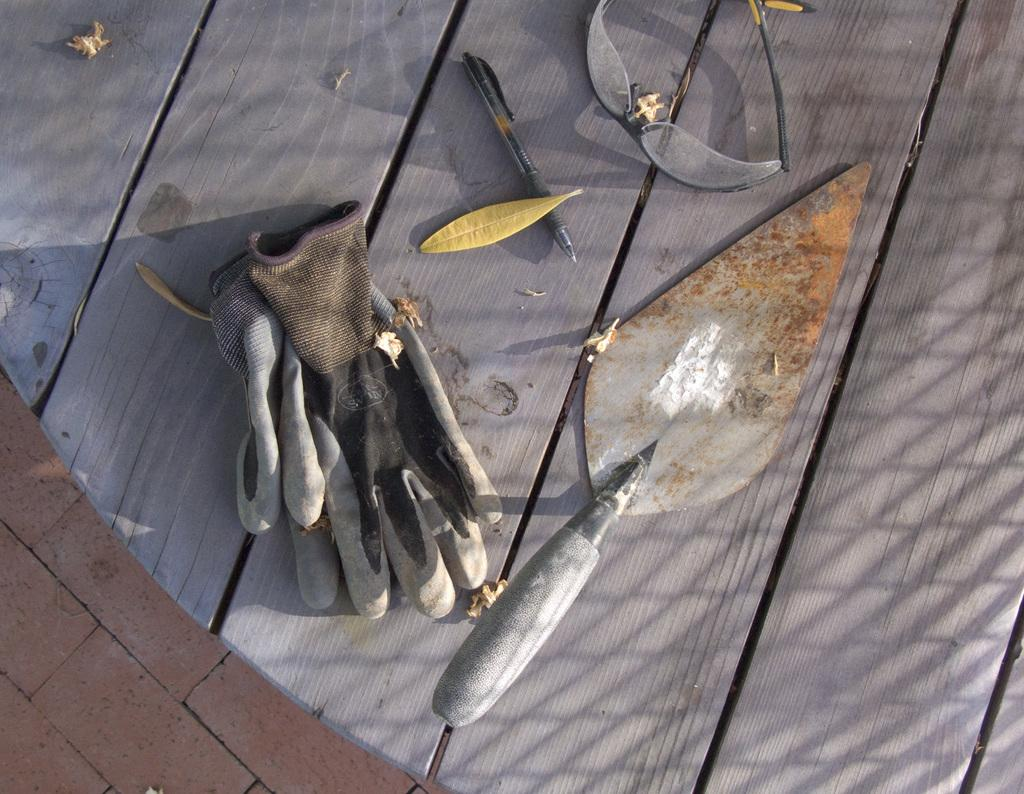What type of objects can be seen in the image? There are gloves, a pen, spectacles, and a trowel in the image. What surface are the objects placed on? The objects are placed on a wooden surface. Are there any natural elements present on the wooden surface? Yes, leaves are present on the wooden surface. What type of canvas is being used to create a painting in the image? There is no canvas or painting present in the image. What is the profit generated from the plantation in the image? There is no plantation or profit mentioned in the image. 